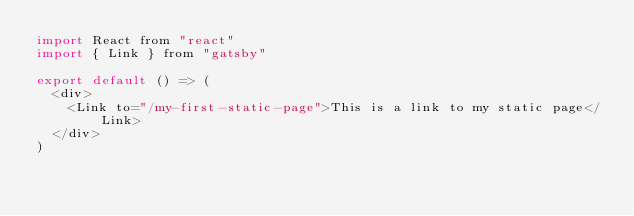<code> <loc_0><loc_0><loc_500><loc_500><_JavaScript_>import React from "react"
import { Link } from "gatsby"

export default () => (
  <div>
    <Link to="/my-first-static-page">This is a link to my static page</Link>
  </div>
)
</code> 